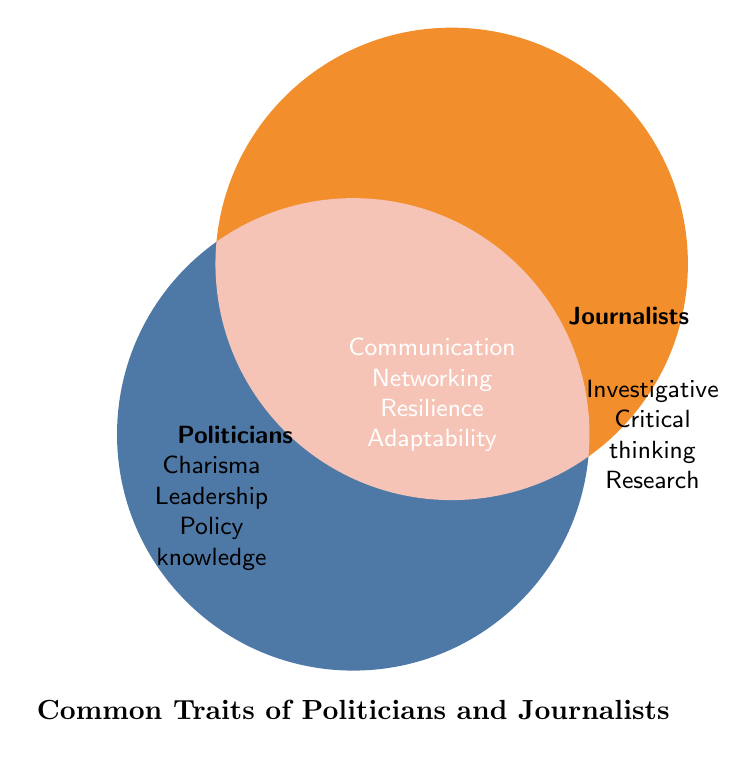What are the common traits shared by both politicians and journalists? Traits that are listed in the overlapping area of the Venn Diagram represent common traits. These traits are: Strong communication, Networking abilities, Resilience under pressure, Adaptability, Public visibility, Deadline-driven, Thick skin
Answer: Strong communication, Networking abilities, Resilience under pressure, Adaptability, Public visibility, Deadline-driven, Thick skin Which trait is unique to politicians but not shared with journalists? Traits listed exclusively on the politicians' side of the Venn Diagram are unique to them. These traits are Charisma, Public speaking, Leadership, Policy knowledge, Fundraising skills, Constituency management, Diplomatic skills
Answer: Charisma, Public speaking, Leadership, Policy knowledge, Fundraising skills, Constituency management, Diplomatic skills List the traits unique to journalists. Traits listed exclusively on the journalists' side of the Venn Diagram are unique to them. These traits are Investigative skills, Critical thinking, Writing proficiency, Fact-checking, Interview techniques, Research skills, Storytelling ability
Answer: Investigative skills, Critical thinking, Writing proficiency, Fact-checking, Interview techniques, Research skills, Storytelling ability How many traits are common between politicians and journalists? Counting the number of traits in the overlapping area of the Venn Diagram, we get a total of 7 traits: Strong communication, Networking abilities, Resilience under pressure, Adaptability, Public visibility, Deadline-driven, Thick skin
Answer: 7 What is the title of the Venn Diagram? The title is generally written below or above the figure and is clearly stated. The title of the Venn Diagram is "Common Traits of Politicians and Journalists"
Answer: Common Traits of Politicians and Journalists What trait involves managing one's audience or supporters? The trait involving managing one's audience or supporters is listed exclusively on the politicians' side and it is Constituency management
Answer: Constituency management Which common trait helps both roles deal with unexpected situations? A trait that helps in dealing with unexpected situations is Adaptability, found in the overlapping area of the Venn Diagram
Answer: Adaptability 